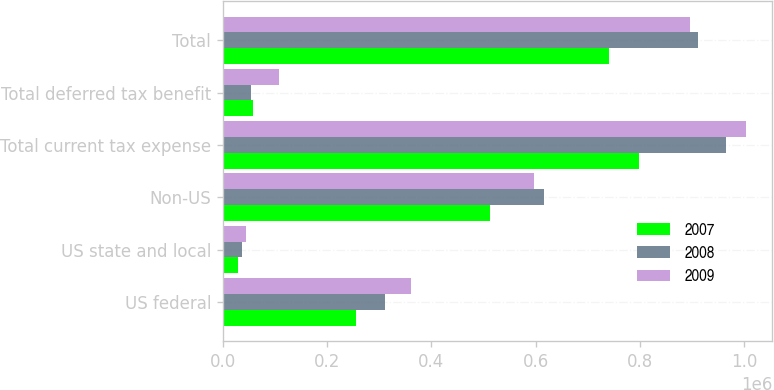<chart> <loc_0><loc_0><loc_500><loc_500><stacked_bar_chart><ecel><fcel>US federal<fcel>US state and local<fcel>Non-US<fcel>Total current tax expense<fcel>Total deferred tax benefit<fcel>Total<nl><fcel>2007<fcel>256379<fcel>30187<fcel>511890<fcel>798456<fcel>58866<fcel>739590<nl><fcel>2008<fcel>311270<fcel>37774<fcel>615306<fcel>964350<fcel>53776<fcel>910574<nl><fcel>2009<fcel>361351<fcel>44394<fcel>597218<fcel>1.00296e+06<fcel>107102<fcel>895861<nl></chart> 